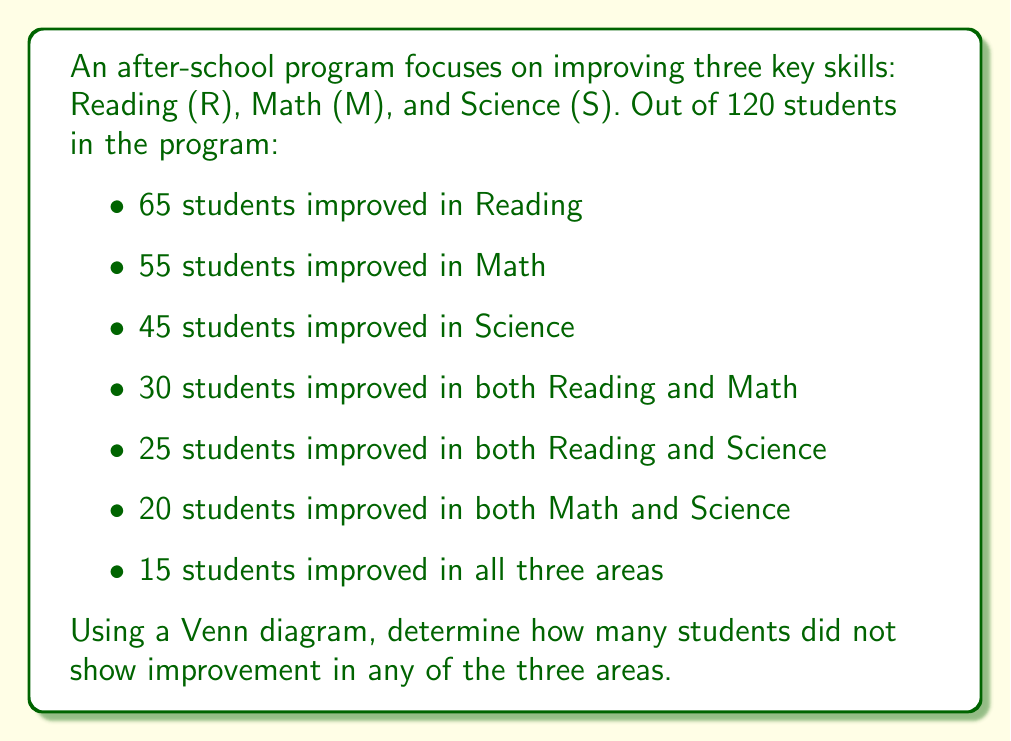What is the answer to this math problem? Let's approach this step-by-step using a Venn diagram and set theory:

1) First, let's draw a Venn diagram with three intersecting circles representing Reading (R), Math (M), and Science (S).

2) We can fill in the known information:
   - $n(R \cap M \cap S) = 15$ (center)
   - $n(R \cap M) - n(R \cap M \cap S) = 30 - 15 = 15$
   - $n(R \cap S) - n(R \cap M \cap S) = 25 - 15 = 10$
   - $n(M \cap S) - n(R \cap M \cap S) = 20 - 15 = 5$

3) Now, let's calculate the number of students in each skill area only:
   - Reading only: $n(R) - n(R \cap M) - n(R \cap S) + n(R \cap M \cap S) = 65 - 30 - 25 + 15 = 25$
   - Math only: $n(M) - n(R \cap M) - n(M \cap S) + n(R \cap M \cap S) = 55 - 30 - 20 + 15 = 20$
   - Science only: $n(S) - n(R \cap S) - n(M \cap S) + n(R \cap M \cap S) = 45 - 25 - 20 + 15 = 15$

4) Now we can sum up all the areas in the Venn diagram:
   $15 + 15 + 10 + 5 + 25 + 20 + 15 = 105$

5) The total number of students who improved in at least one area is 105.

6) To find the number of students who didn't improve in any area, we subtract this from the total number of students:
   $120 - 105 = 15$

Therefore, 15 students did not show improvement in any of the three areas.
Answer: 15 students 